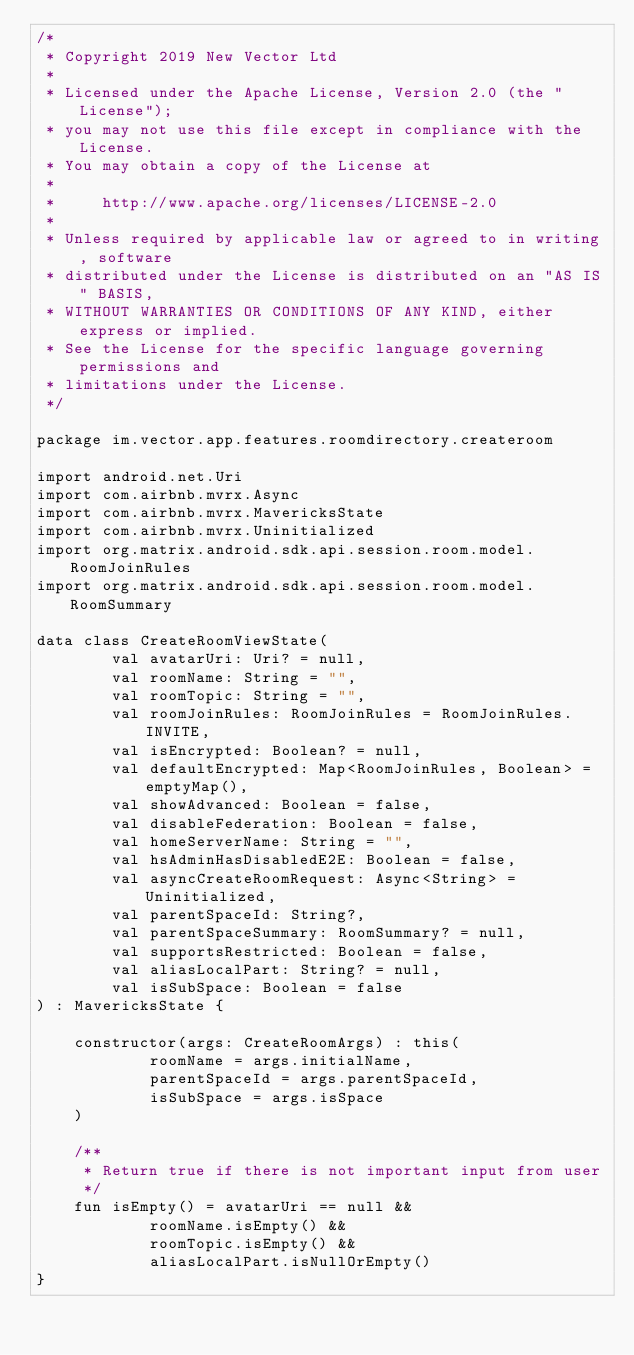<code> <loc_0><loc_0><loc_500><loc_500><_Kotlin_>/*
 * Copyright 2019 New Vector Ltd
 *
 * Licensed under the Apache License, Version 2.0 (the "License");
 * you may not use this file except in compliance with the License.
 * You may obtain a copy of the License at
 *
 *     http://www.apache.org/licenses/LICENSE-2.0
 *
 * Unless required by applicable law or agreed to in writing, software
 * distributed under the License is distributed on an "AS IS" BASIS,
 * WITHOUT WARRANTIES OR CONDITIONS OF ANY KIND, either express or implied.
 * See the License for the specific language governing permissions and
 * limitations under the License.
 */

package im.vector.app.features.roomdirectory.createroom

import android.net.Uri
import com.airbnb.mvrx.Async
import com.airbnb.mvrx.MavericksState
import com.airbnb.mvrx.Uninitialized
import org.matrix.android.sdk.api.session.room.model.RoomJoinRules
import org.matrix.android.sdk.api.session.room.model.RoomSummary

data class CreateRoomViewState(
        val avatarUri: Uri? = null,
        val roomName: String = "",
        val roomTopic: String = "",
        val roomJoinRules: RoomJoinRules = RoomJoinRules.INVITE,
        val isEncrypted: Boolean? = null,
        val defaultEncrypted: Map<RoomJoinRules, Boolean> = emptyMap(),
        val showAdvanced: Boolean = false,
        val disableFederation: Boolean = false,
        val homeServerName: String = "",
        val hsAdminHasDisabledE2E: Boolean = false,
        val asyncCreateRoomRequest: Async<String> = Uninitialized,
        val parentSpaceId: String?,
        val parentSpaceSummary: RoomSummary? = null,
        val supportsRestricted: Boolean = false,
        val aliasLocalPart: String? = null,
        val isSubSpace: Boolean = false
) : MavericksState {

    constructor(args: CreateRoomArgs) : this(
            roomName = args.initialName,
            parentSpaceId = args.parentSpaceId,
            isSubSpace = args.isSpace
    )

    /**
     * Return true if there is not important input from user
     */
    fun isEmpty() = avatarUri == null &&
            roomName.isEmpty() &&
            roomTopic.isEmpty() &&
            aliasLocalPart.isNullOrEmpty()
}
</code> 